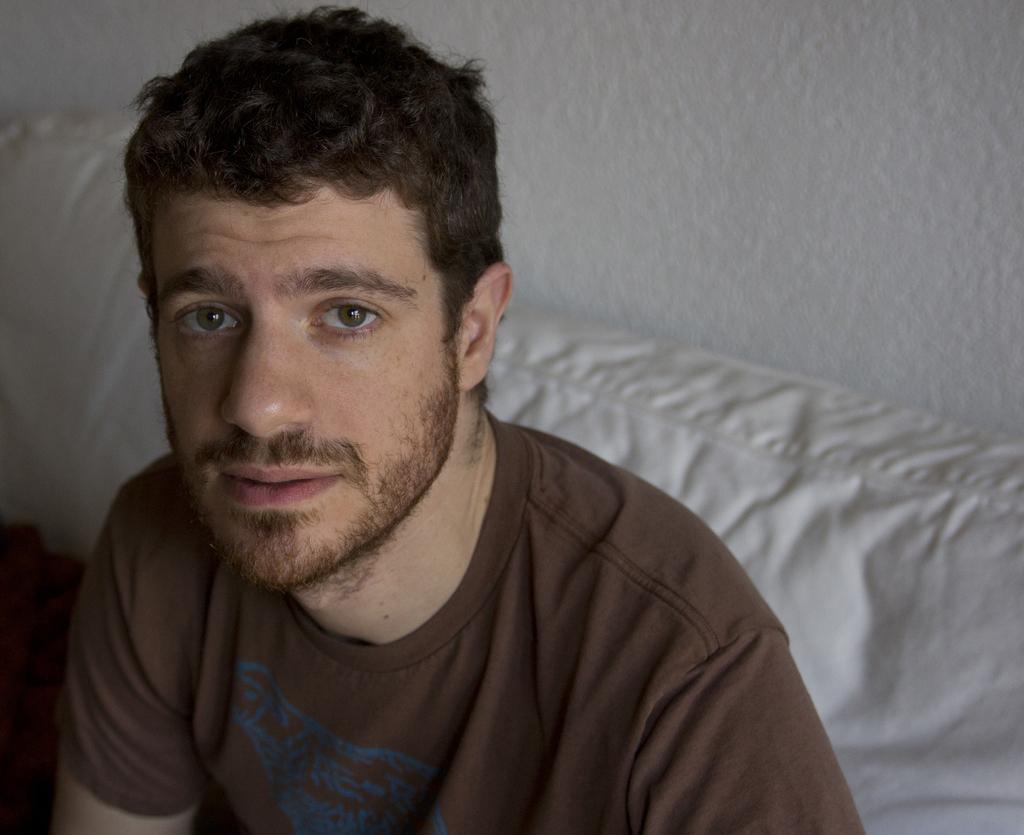In one or two sentences, can you explain what this image depicts? A man is looking at his side, he wore chocolate color t-shirt. This is the wall in this image. 